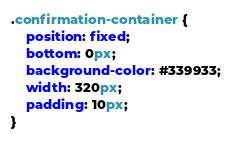<code> <loc_0><loc_0><loc_500><loc_500><_CSS_>.confirmation-container {
    position: fixed;
    bottom: 0px;
    background-color: #339933;
    width: 320px;
    padding: 10px;
}</code> 